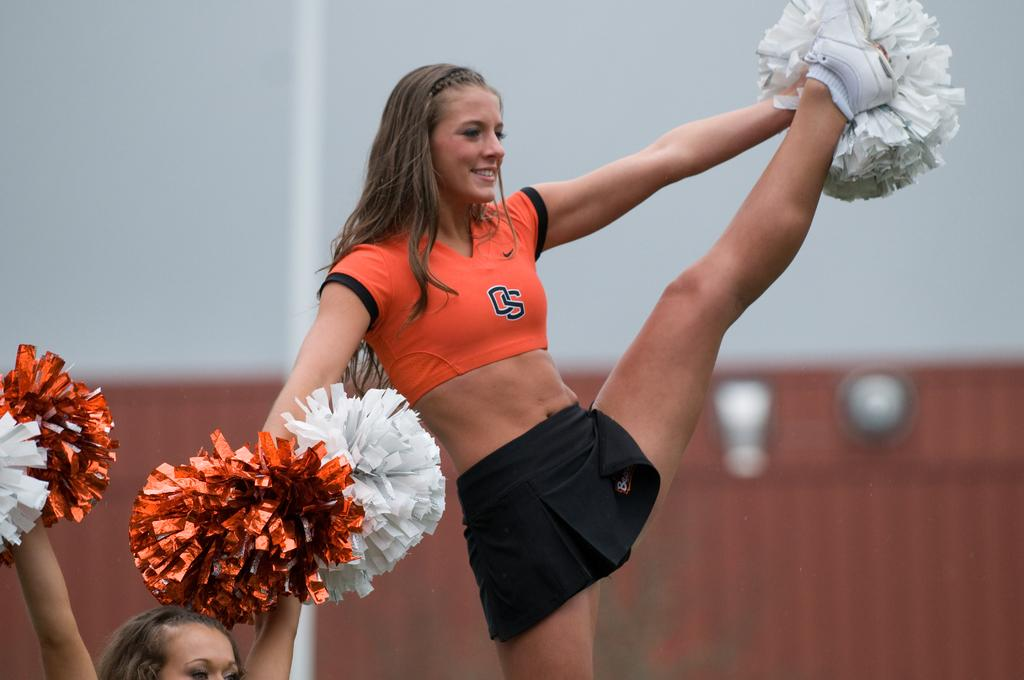<image>
Give a short and clear explanation of the subsequent image. a cheerleader that has DS on her shirt 